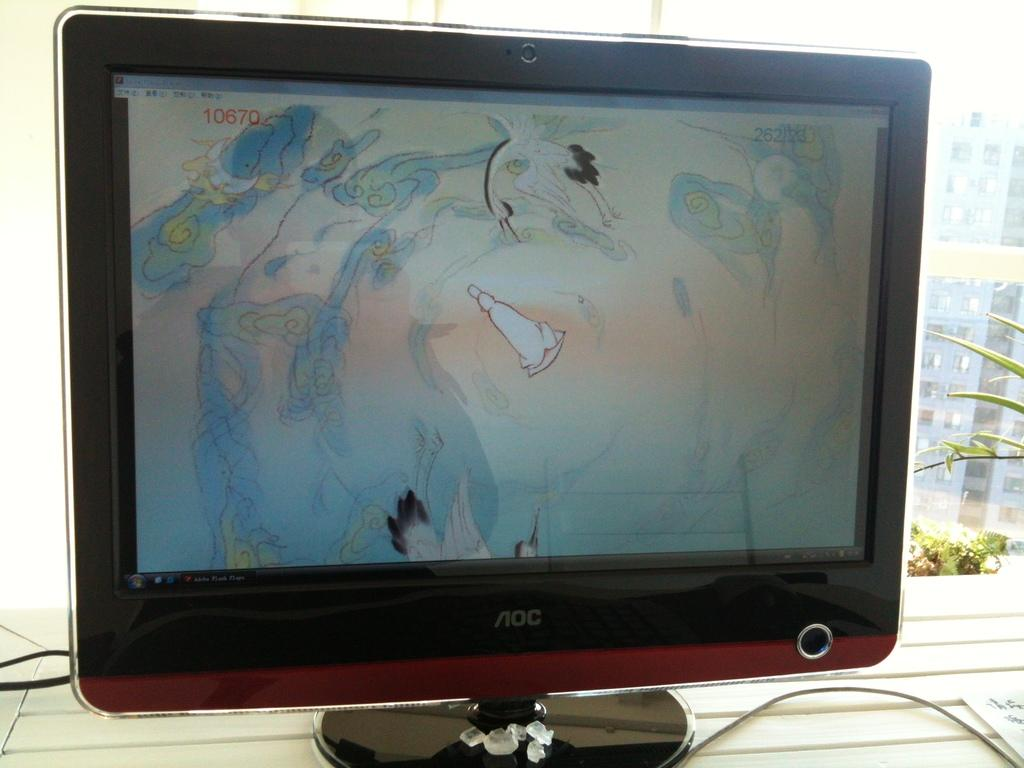What is on the table in the image? There is a monitor on a table in the image. What can be seen through the glass wall in the image? There is a view of plants and a building visible through the glass wall. How are the plants and building visible in the image? The view of plants and the building is visible through a glass wall. What type of rice is being cooked in the image? There is no rice present in the image. How does the income of the person in the image affect the view of the plants and building? There is no information about the person's income or any indication that it would affect the view of the plants and building in the image. 